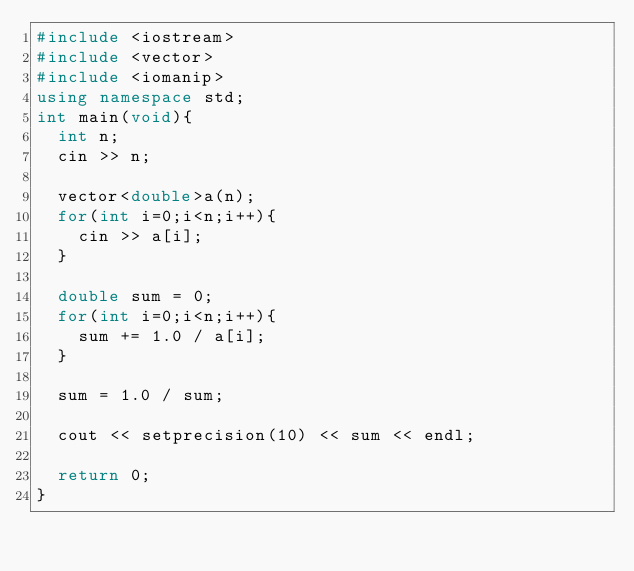<code> <loc_0><loc_0><loc_500><loc_500><_C++_>#include <iostream>
#include <vector>
#include <iomanip>
using namespace std;
int main(void){
  int n;
  cin >> n;
  
  vector<double>a(n);
  for(int i=0;i<n;i++){
    cin >> a[i];
  }
  
  double sum = 0;
  for(int i=0;i<n;i++){
    sum += 1.0 / a[i];
  }
  
  sum = 1.0 / sum;
  
  cout << setprecision(10) << sum << endl;
  
  return 0;
}
  </code> 